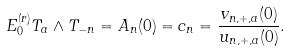Convert formula to latex. <formula><loc_0><loc_0><loc_500><loc_500>E _ { 0 } ^ { ( r ) } T _ { a } \wedge T _ { - n } = A _ { n } ( 0 ) = c _ { n } = \frac { v _ { n , + , a } ( 0 ) } { u _ { n , + , a } ( 0 ) } .</formula> 